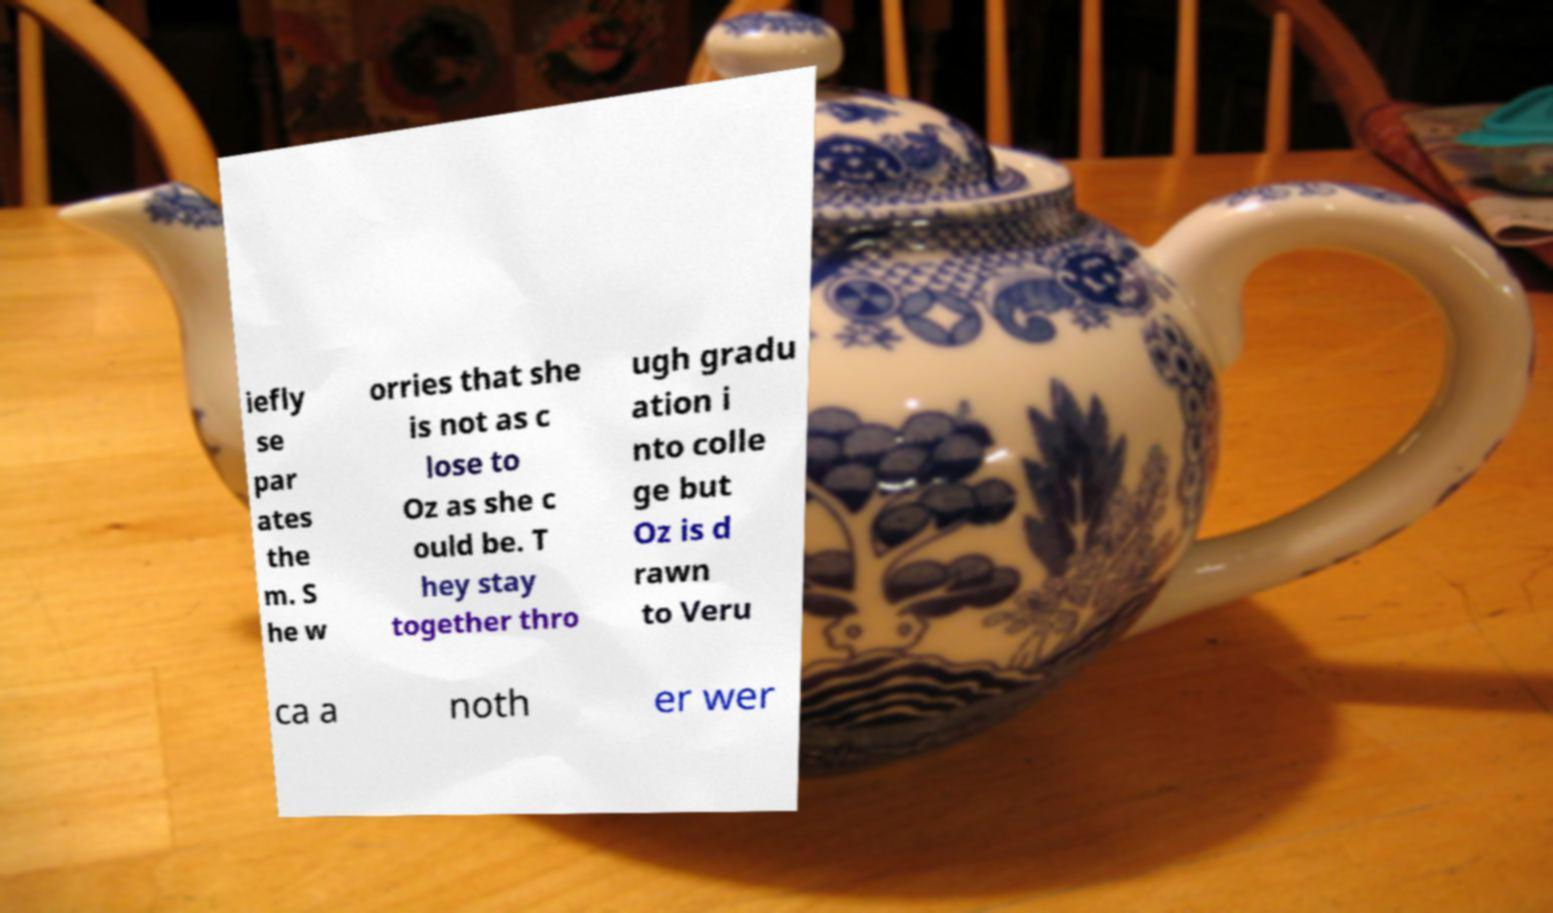What messages or text are displayed in this image? I need them in a readable, typed format. iefly se par ates the m. S he w orries that she is not as c lose to Oz as she c ould be. T hey stay together thro ugh gradu ation i nto colle ge but Oz is d rawn to Veru ca a noth er wer 